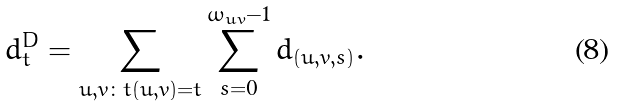<formula> <loc_0><loc_0><loc_500><loc_500>d ^ { D } _ { t } = \sum _ { u , v \colon t ( u , v ) = t } \sum _ { s = 0 } ^ { \omega _ { u v } - 1 } d _ { ( u , v , s ) } .</formula> 